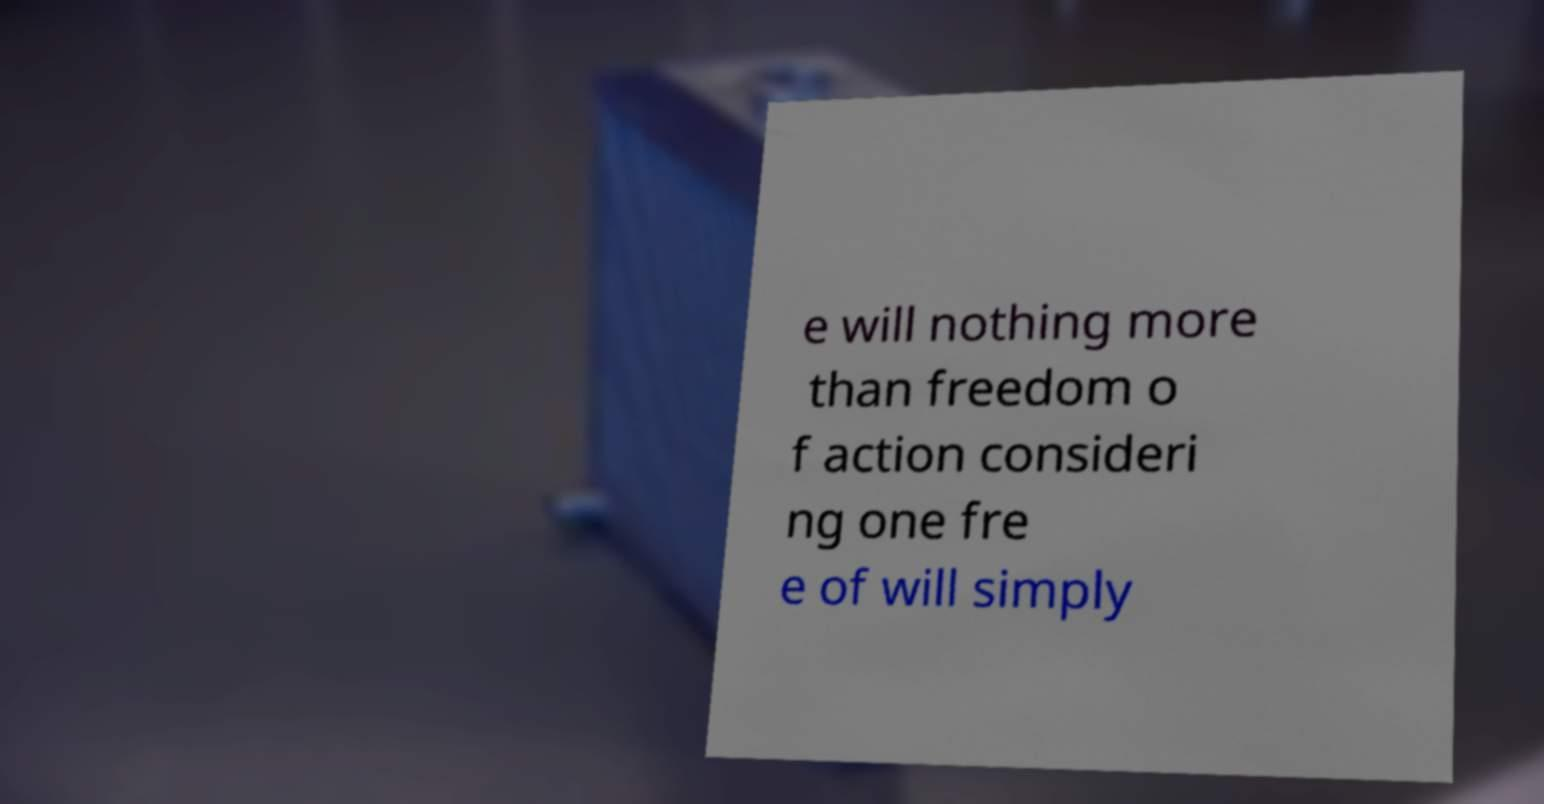Can you read and provide the text displayed in the image?This photo seems to have some interesting text. Can you extract and type it out for me? e will nothing more than freedom o f action consideri ng one fre e of will simply 